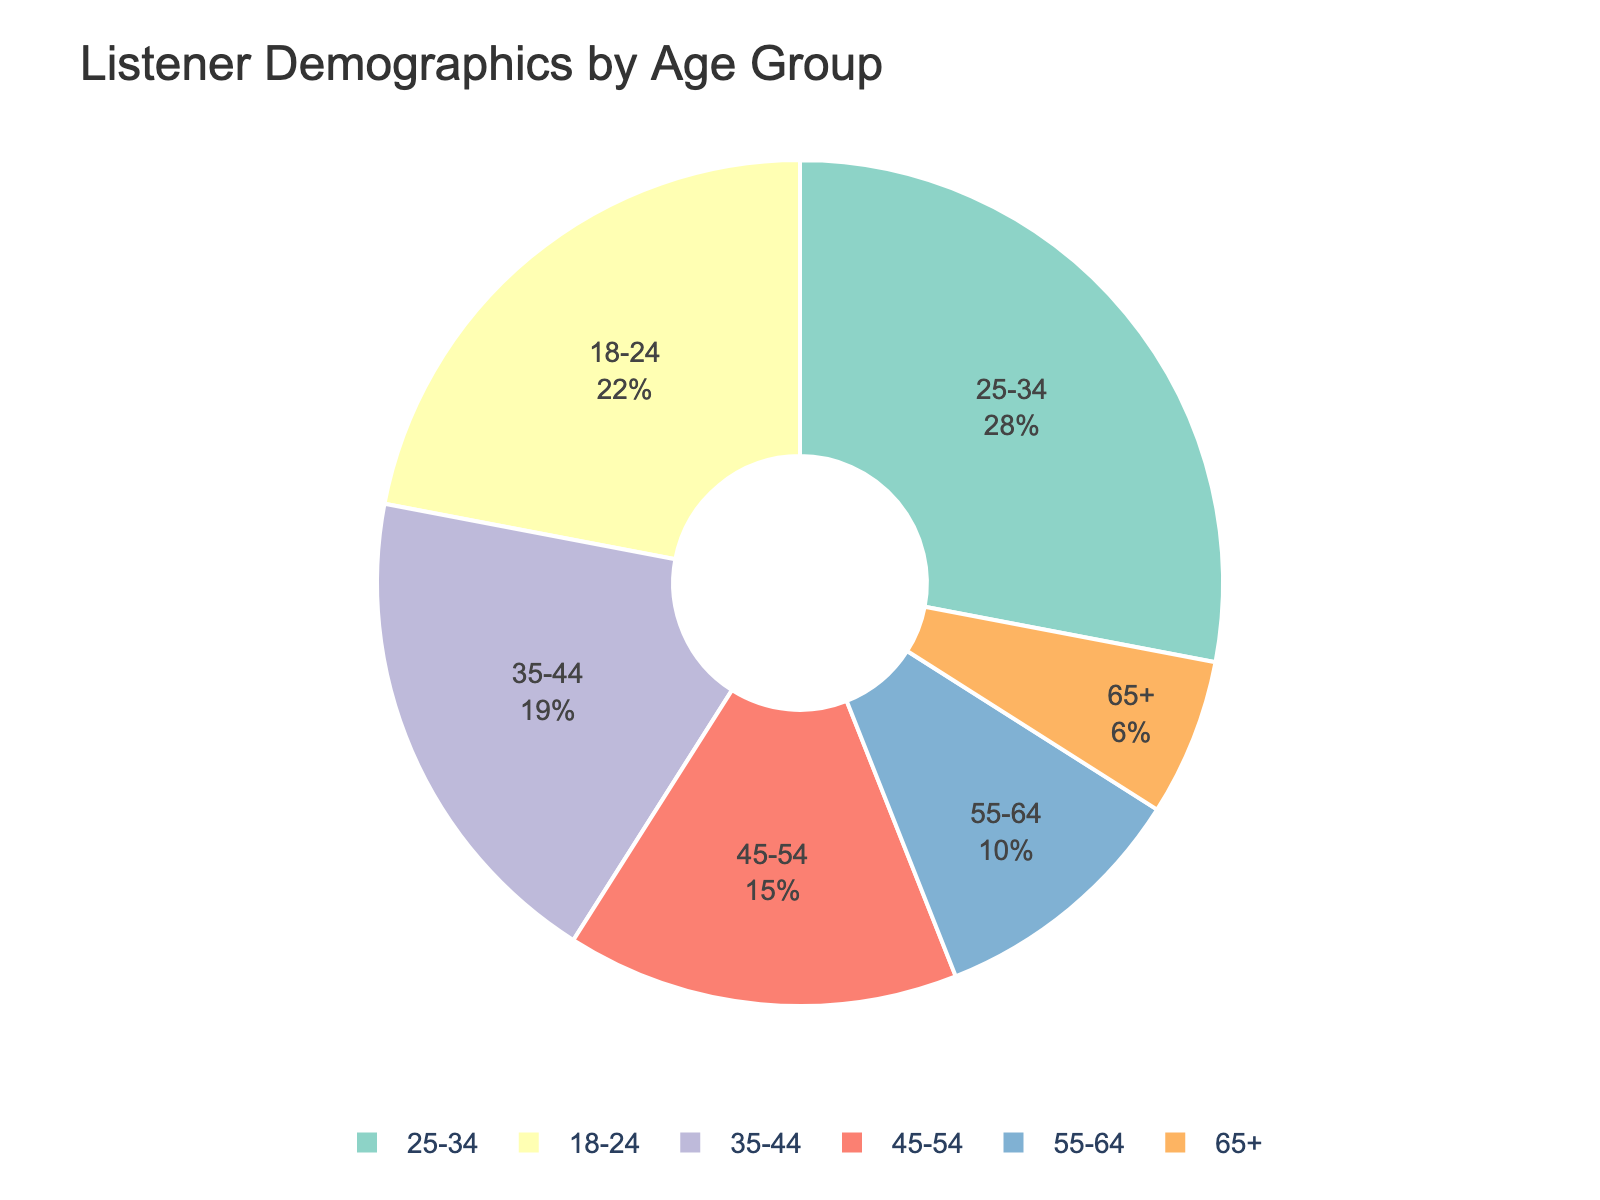What age group has the highest percentage of listeners? The age group with the highest percentage of listeners is the one that occupies the largest portion of the pie chart. This is the 25-34 age group at 28%.
Answer: 25-34 Which two age groups combined make up the smallest percentage of listeners? To find this, we need to look for the two smallest segments in the pie chart and add their percentages. The 65+ age group has 6%, and the 55-64 age group has 10%. Combined, they make 16%.
Answer: 55-64 and 65+ What is the difference in percentage between the 25-34 and the 18-24 age groups? Subtract the percentage of the 18-24 age group from the 25-34 age group. 28% - 22% = 6%.
Answer: 6% Which age groups have a lower percentage than the 35-44 age group? From the pie chart, the age groups with a lower percentage than 19% are 45-54 (15%), 55-64 (10%), and 65+ (6%).
Answer: 45-54, 55-64, 65+ How does the percentage of listeners aged 45-54 compare with those aged 18-24? Compare the percentages of both age groups. The 45-54 age group has 15%, while the 18-24 age group has 22%, making the latter larger.
Answer: Less What is the combined percentage of listeners aged 35-54? Add the percentages of the 35-44 age group and the 45-54 age group. 19% + 15% = 34%.
Answer: 34% If we exclude the 18-24 and 25-34 age groups, what percentage of listeners remain? Subtract the sum of the percentages of the 18-24 and 25-34 age groups from 100%. 100% - (22% + 28%) = 50%.
Answer: 50% Which age group in the pie chart has the second-lowest percentage of listeners? Identify the age group with the second-smallest segment after the smallest one (65+ with 6%). The 55-64 age group has 10%, making it the second-lowest.
Answer: 55-64 